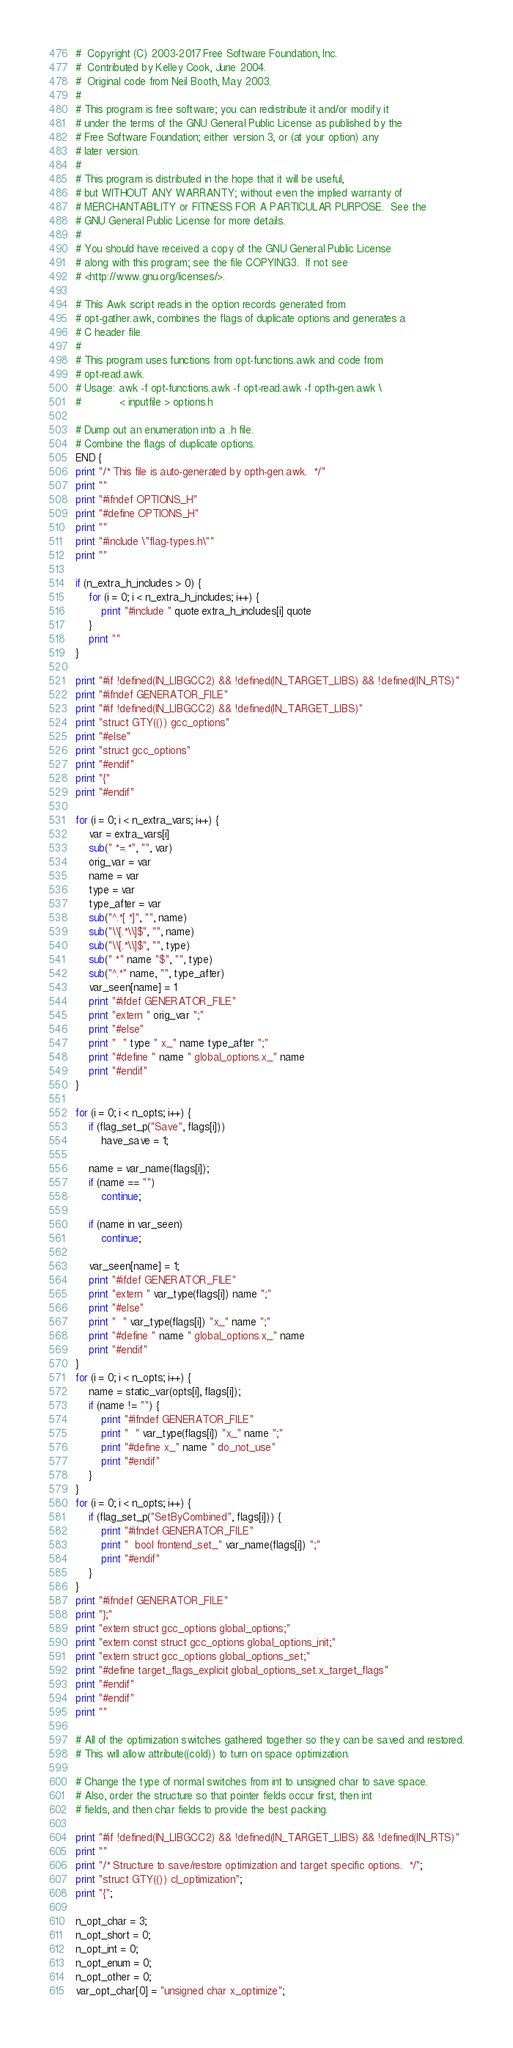Convert code to text. <code><loc_0><loc_0><loc_500><loc_500><_Awk_>#  Copyright (C) 2003-2017 Free Software Foundation, Inc.
#  Contributed by Kelley Cook, June 2004.
#  Original code from Neil Booth, May 2003.
#
# This program is free software; you can redistribute it and/or modify it
# under the terms of the GNU General Public License as published by the
# Free Software Foundation; either version 3, or (at your option) any
# later version.
# 
# This program is distributed in the hope that it will be useful,
# but WITHOUT ANY WARRANTY; without even the implied warranty of
# MERCHANTABILITY or FITNESS FOR A PARTICULAR PURPOSE.  See the
# GNU General Public License for more details.
# 
# You should have received a copy of the GNU General Public License
# along with this program; see the file COPYING3.  If not see
# <http://www.gnu.org/licenses/>.

# This Awk script reads in the option records generated from 
# opt-gather.awk, combines the flags of duplicate options and generates a
# C header file.
#
# This program uses functions from opt-functions.awk and code from
# opt-read.awk.
# Usage: awk -f opt-functions.awk -f opt-read.awk -f opth-gen.awk \
#            < inputfile > options.h

# Dump out an enumeration into a .h file.
# Combine the flags of duplicate options.
END {
print "/* This file is auto-generated by opth-gen.awk.  */"
print ""
print "#ifndef OPTIONS_H"
print "#define OPTIONS_H"
print ""
print "#include \"flag-types.h\""
print ""

if (n_extra_h_includes > 0) {
	for (i = 0; i < n_extra_h_includes; i++) {
		print "#include " quote extra_h_includes[i] quote
	}
	print ""
}

print "#if !defined(IN_LIBGCC2) && !defined(IN_TARGET_LIBS) && !defined(IN_RTS)"
print "#ifndef GENERATOR_FILE"
print "#if !defined(IN_LIBGCC2) && !defined(IN_TARGET_LIBS)"
print "struct GTY(()) gcc_options"
print "#else"
print "struct gcc_options"
print "#endif"
print "{"
print "#endif"

for (i = 0; i < n_extra_vars; i++) {
	var = extra_vars[i]
	sub(" *=.*", "", var)
	orig_var = var
	name = var
	type = var
	type_after = var
	sub("^.*[ *]", "", name)
	sub("\\[.*\\]$", "", name)
	sub("\\[.*\\]$", "", type)
	sub(" *" name "$", "", type)
	sub("^.*" name, "", type_after)
	var_seen[name] = 1
	print "#ifdef GENERATOR_FILE"
	print "extern " orig_var ";"
	print "#else"
	print "  " type " x_" name type_after ";"
	print "#define " name " global_options.x_" name
	print "#endif"
}

for (i = 0; i < n_opts; i++) {
	if (flag_set_p("Save", flags[i]))
		have_save = 1;

	name = var_name(flags[i]);
	if (name == "")
		continue;

	if (name in var_seen)
		continue;

	var_seen[name] = 1;
	print "#ifdef GENERATOR_FILE"
	print "extern " var_type(flags[i]) name ";"
	print "#else"
	print "  " var_type(flags[i]) "x_" name ";"
	print "#define " name " global_options.x_" name
	print "#endif"
}
for (i = 0; i < n_opts; i++) {
	name = static_var(opts[i], flags[i]);
	if (name != "") {
		print "#ifndef GENERATOR_FILE"
		print "  " var_type(flags[i]) "x_" name ";"
		print "#define x_" name " do_not_use"
		print "#endif"
	}
}
for (i = 0; i < n_opts; i++) {
	if (flag_set_p("SetByCombined", flags[i])) {
		print "#ifndef GENERATOR_FILE"
		print "  bool frontend_set_" var_name(flags[i]) ";"
		print "#endif"
	}
}
print "#ifndef GENERATOR_FILE"
print "};"
print "extern struct gcc_options global_options;"
print "extern const struct gcc_options global_options_init;"
print "extern struct gcc_options global_options_set;"
print "#define target_flags_explicit global_options_set.x_target_flags"
print "#endif"
print "#endif"
print ""

# All of the optimization switches gathered together so they can be saved and restored.
# This will allow attribute((cold)) to turn on space optimization.

# Change the type of normal switches from int to unsigned char to save space.
# Also, order the structure so that pointer fields occur first, then int
# fields, and then char fields to provide the best packing.

print "#if !defined(IN_LIBGCC2) && !defined(IN_TARGET_LIBS) && !defined(IN_RTS)"
print ""
print "/* Structure to save/restore optimization and target specific options.  */";
print "struct GTY(()) cl_optimization";
print "{";

n_opt_char = 3;
n_opt_short = 0;
n_opt_int = 0;
n_opt_enum = 0;
n_opt_other = 0;
var_opt_char[0] = "unsigned char x_optimize";</code> 